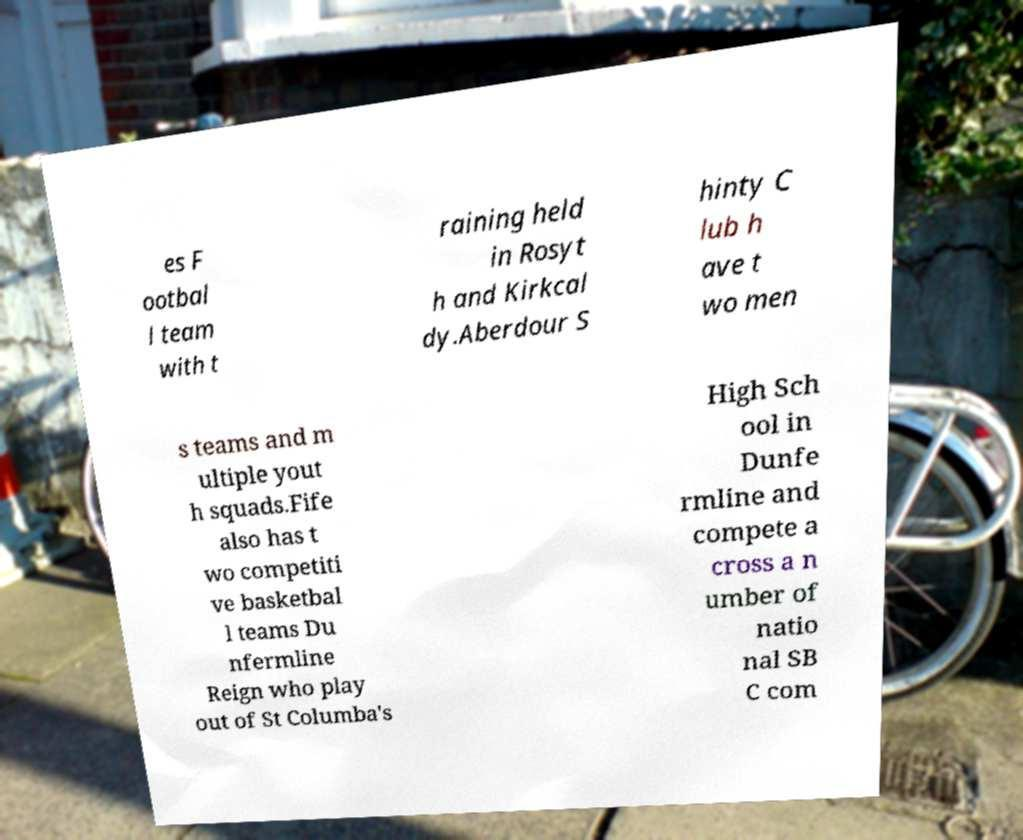There's text embedded in this image that I need extracted. Can you transcribe it verbatim? es F ootbal l team with t raining held in Rosyt h and Kirkcal dy.Aberdour S hinty C lub h ave t wo men s teams and m ultiple yout h squads.Fife also has t wo competiti ve basketbal l teams Du nfermline Reign who play out of St Columba's High Sch ool in Dunfe rmline and compete a cross a n umber of natio nal SB C com 